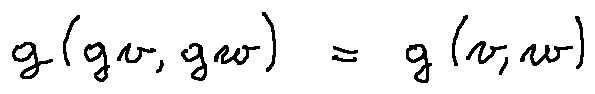Convert formula to latex. <formula><loc_0><loc_0><loc_500><loc_500>g ( g v , g w ) = g ( v , w )</formula> 